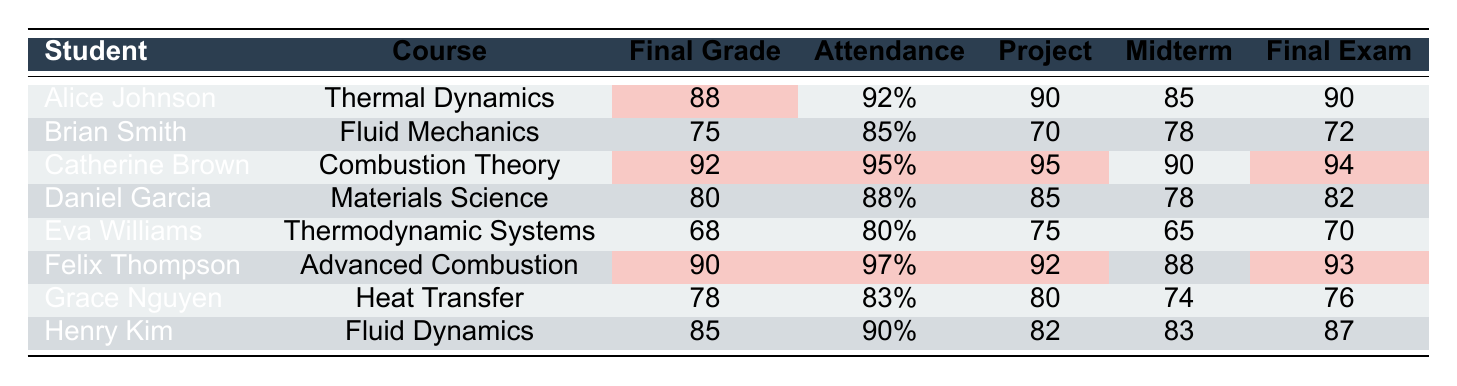What is the final grade of Alice Johnson? The table shows that Alice Johnson's final grade is clearly marked under the "Final Grade" column next to her name. It states her final grade is 88.
Answer: 88 What is the attendance rate of Brian Smith? By checking the "Attendance" column for Brian Smith, we can see that his attendance rate is listed as 85%.
Answer: 85% Which student scored the highest in the final exam? To find this, we compare the values in the "Final Exam" column. Catherine Brown has the highest score of 94.
Answer: 94 How many students have a final grade above 80? We will examine each student's final grade, counting those who exceed 80. Alice (88), Catherine (92), Daniel (80), Felix (90), and Henry (85) qualify, totaling 5 students.
Answer: 5 What is the average final grade of all students? We sum all final grades: 88 + 75 + 92 + 80 + 68 + 90 + 78 + 85 = 686. There are 8 students, so the average is 686 / 8 = 85.75.
Answer: 85.75 Did any student score below 70 in any component? We look for any grades in the columns below 70. Eva Williams has a project grade of 75 and both midterm and final exam scores of 65 and 70, respectively, confirming she scored below 70 in one component.
Answer: Yes Which course has the lowest final grade among the students? We compare the final grades across all courses. The lowest final grade is from Eva Williams in "Thermodynamic Systems," with a score of 68.
Answer: Thermodynamic Systems What is the difference in final grade between the student with the highest and lowest final grades? The highest final grade is from Catherine Brown (92) and the lowest is from Eva Williams (68). The difference is 92 - 68 = 24.
Answer: 24 How many students have an attendance rate of 90% or higher? We can check the "Attendance" column and count the students. Alice (92%), Catherine (95%), and Felix (97%) all have rates above 90%. Therefore, there are 3 students.
Answer: 3 Is Felix Thompson's project grade higher than his midterm exam score? We compare Felix's project grade (92) and his midterm exam score (88). Since 92 is greater than 88, the statement is true.
Answer: Yes If we consider only students from the combustion courses, who had better final grades, Alice Johnson or Felix Thompson? We see Alice is in "Thermal Dynamics" with a final grade of 88, while Felix in "Advanced Combustion" has a final grade of 90. Thus, Felix performed better.
Answer: Felix Thompson 